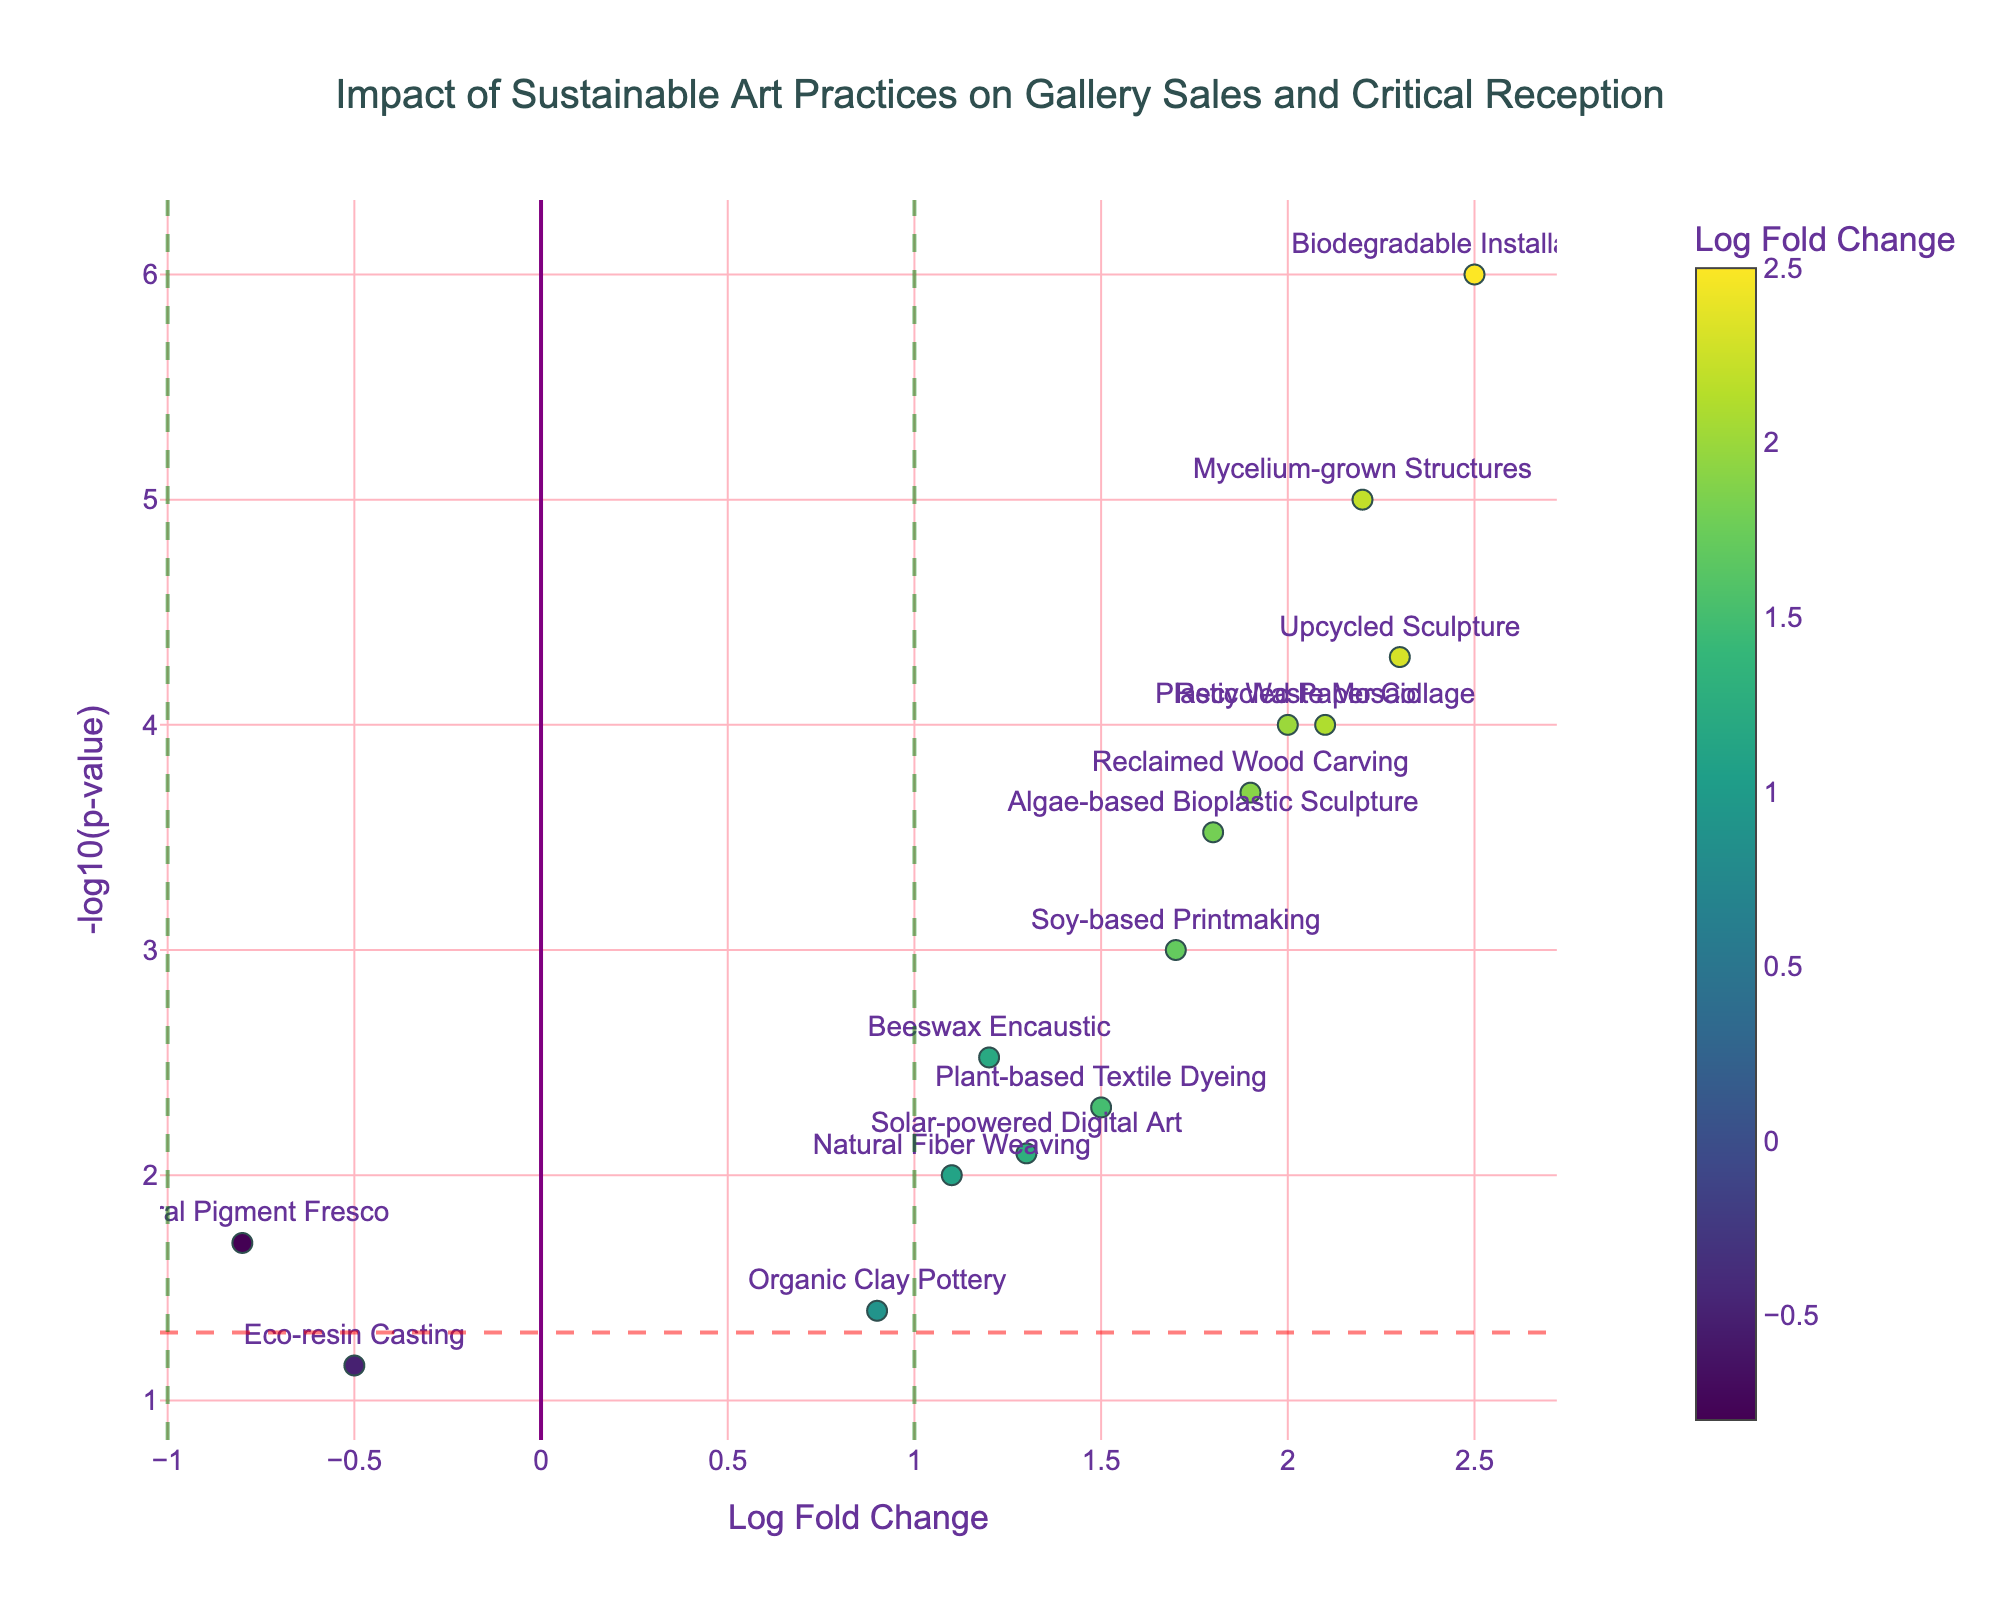What's the title of the plot? The title is prominently displayed at the top of the plot. It reads "Impact of Sustainable Art Practices on Gallery Sales and Critical Reception"
Answer: Impact of Sustainable Art Practices on Gallery Sales and Critical Reception Which art technique has the highest -log10(p-value)? The -log10(p-value) is highest for "Biodegradable Installation Art," which is located at the topmost point on the y-axis.
Answer: Biodegradable Installation Art What is the log fold change for Recycled Paper Collage? The log fold change for "Recycled Paper Collage" can be obtained by locating the marker labeled with the technique name. Its position on the x-axis corresponds to its value.
Answer: 2.1 Which two techniques have log fold changes greater than 2 and very small p-values? Techniques with log fold changes greater than 2 are those positioned to the right of 2 on the x-axis. Look for techniques with very high -log10(p-values) on the y-axis. The two techniques are "Upcycled Sculpture" and "Mycelium-grown Structures."
Answer: Upcycled Sculpture, Mycelium-grown Structures How many art techniques are not statistically significant at the p < 0.05 level? Art techniques that are not statistically significant at the p < 0.05 level fall below the horizontal red line on the y-axis, indicating a -log10(p-value) less than 1.3. The only techniques below this threshold are "Eco-resin Casting."
Answer: One Which art technique shows the lowest log fold change and is it statistically significant? The lowest log fold change is seen at the leftmost point on the x-axis. "Natural Pigment Fresco" has a log fold change of -0.8. Checking its position relative to the horizontal red line, we can confirm if it is statistically significant. Since it is above the red line, it is statistically significant.
Answer: Natural Pigment Fresco, Yes What does the green dashed vertical line at x = 1 indicate in the plot? The vertical dashed green line at x = 1 indicates the threshold for a significant positive log fold change. Art techniques to the right of this line have a log fold change greater than 1.
Answer: Threshold for significant positive log fold change How does "Soy-based Printmaking" compare to "Solar-powered Digital Art" in terms of both log fold change and -log10(p-value)? Locate both techniques on the plot. "Soy-based Printmaking" has a higher log fold change (1.7) compared to "Solar-powered Digital Art" (1.3). It also has a higher -log10(p-value), indicating a lower p-value and thus more significant results.
Answer: Soy-based Printmaking has a higher log fold change and -log10(p-value) Which sustainable art technique has a log fold change close to 1 and is statistically significant? Techniques close to a log fold change of 1 can be found by locating the points near x = 1 on the plot. "Natural Fiber Weaving" has a log fold change of 1.1 and is above the horizontal red line, making it statistically significant.
Answer: Natural Fiber Weaving What is the significance indicated by the color scale in the plot? The color scale in the plot represents the log fold change values. Techniques with different log fold changes are color-coded accordingly, with warmer colors indicating higher positive values and cooler colors indicating lower or negative values.
Answer: Represents log fold change values 